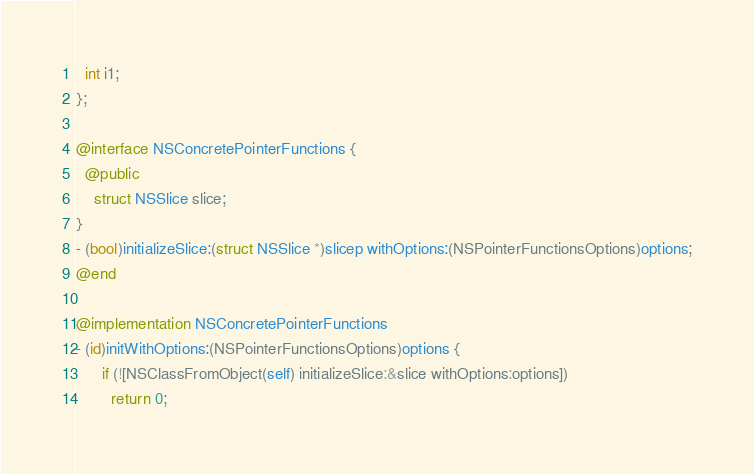<code> <loc_0><loc_0><loc_500><loc_500><_ObjectiveC_>  int i1;
};

@interface NSConcretePointerFunctions {
  @public
    struct NSSlice slice;
}
- (bool)initializeSlice:(struct NSSlice *)slicep withOptions:(NSPointerFunctionsOptions)options;
@end

@implementation NSConcretePointerFunctions
- (id)initWithOptions:(NSPointerFunctionsOptions)options {
      if (![NSClassFromObject(self) initializeSlice:&slice withOptions:options])
        return 0;</code> 